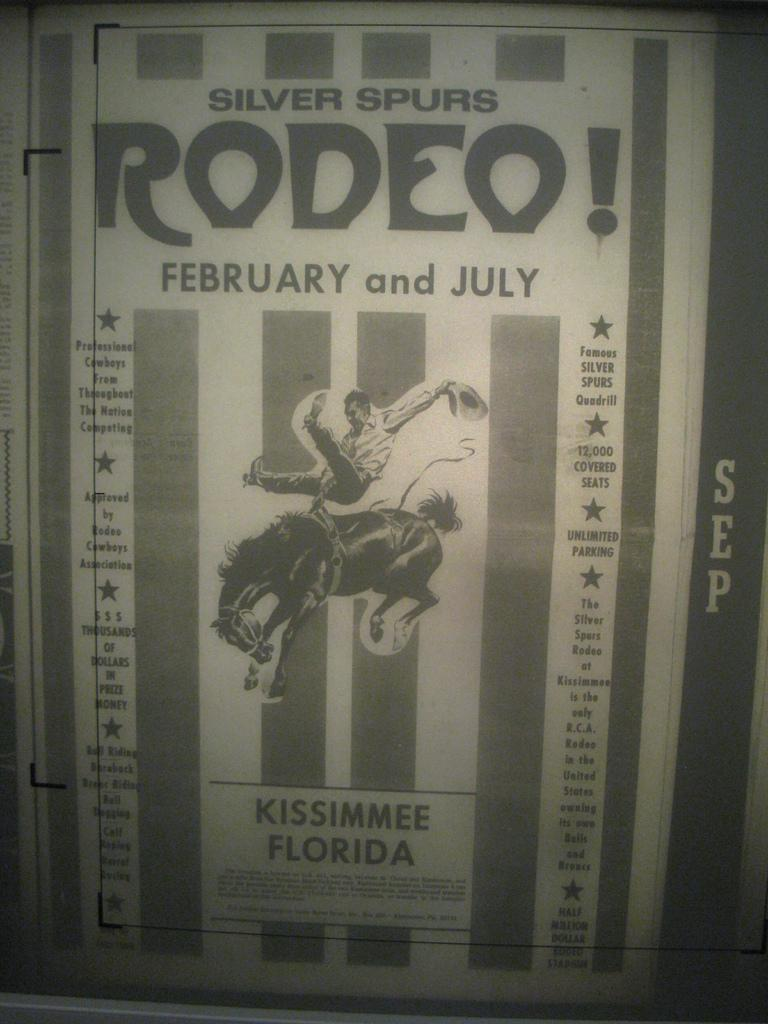<image>
Give a short and clear explanation of the subsequent image. The Silver Spurs Rodeo took place in February and July in Kissimmee, Florida. 